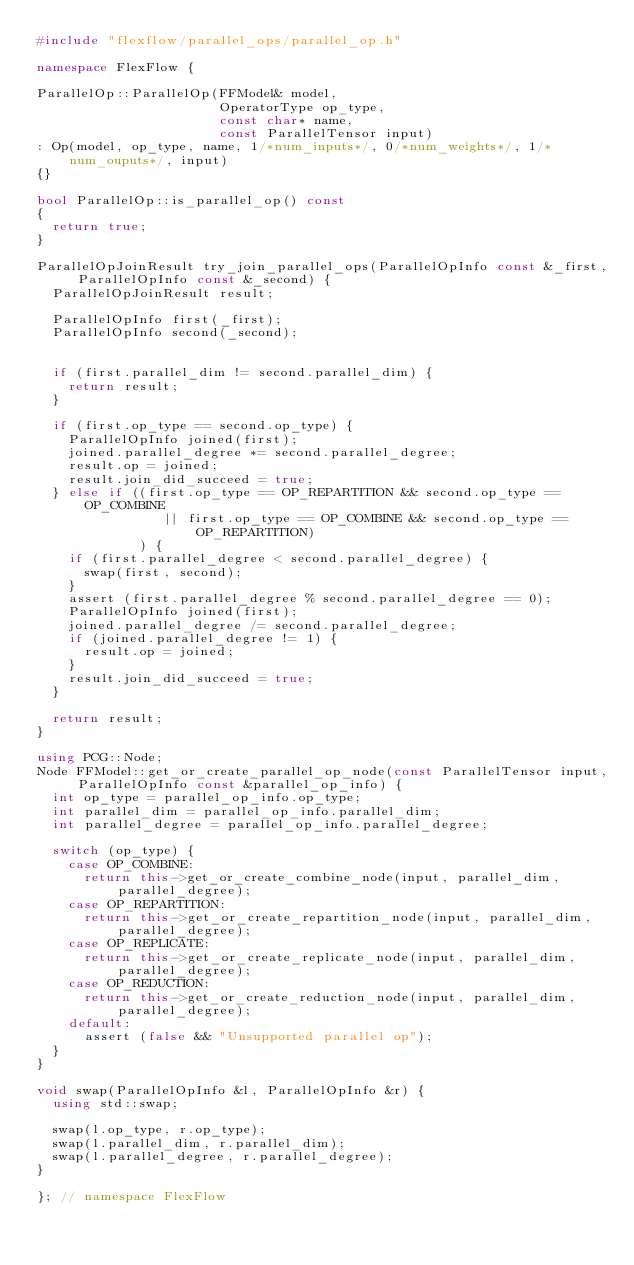Convert code to text. <code><loc_0><loc_0><loc_500><loc_500><_C++_>#include "flexflow/parallel_ops/parallel_op.h"

namespace FlexFlow {

ParallelOp::ParallelOp(FFModel& model,
                       OperatorType op_type,
                       const char* name,
                       const ParallelTensor input)
: Op(model, op_type, name, 1/*num_inputs*/, 0/*num_weights*/, 1/*num_ouputs*/, input)
{}

bool ParallelOp::is_parallel_op() const
{
  return true;
}

ParallelOpJoinResult try_join_parallel_ops(ParallelOpInfo const &_first, ParallelOpInfo const &_second) {
  ParallelOpJoinResult result;

  ParallelOpInfo first(_first);
  ParallelOpInfo second(_second);


  if (first.parallel_dim != second.parallel_dim) {
    return result;
  }
  
  if (first.op_type == second.op_type) {
    ParallelOpInfo joined(first);
    joined.parallel_degree *= second.parallel_degree;
    result.op = joined;
    result.join_did_succeed = true;
  } else if ((first.op_type == OP_REPARTITION && second.op_type == OP_COMBINE
                || first.op_type == OP_COMBINE && second.op_type == OP_REPARTITION) 
             ) {
    if (first.parallel_degree < second.parallel_degree) {
      swap(first, second);
    }
    assert (first.parallel_degree % second.parallel_degree == 0);
    ParallelOpInfo joined(first);
    joined.parallel_degree /= second.parallel_degree;
    if (joined.parallel_degree != 1) {
      result.op = joined;
    }
    result.join_did_succeed = true;
  } 

  return result;
}

using PCG::Node;
Node FFModel::get_or_create_parallel_op_node(const ParallelTensor input, ParallelOpInfo const &parallel_op_info) {
  int op_type = parallel_op_info.op_type;
  int parallel_dim = parallel_op_info.parallel_dim;
  int parallel_degree = parallel_op_info.parallel_degree;

  switch (op_type) {
    case OP_COMBINE:
      return this->get_or_create_combine_node(input, parallel_dim, parallel_degree);
    case OP_REPARTITION:
      return this->get_or_create_repartition_node(input, parallel_dim, parallel_degree);
    case OP_REPLICATE:
      return this->get_or_create_replicate_node(input, parallel_dim, parallel_degree);
    case OP_REDUCTION:
      return this->get_or_create_reduction_node(input, parallel_dim, parallel_degree);
    default:
      assert (false && "Unsupported parallel op");
  }
}

void swap(ParallelOpInfo &l, ParallelOpInfo &r) {
  using std::swap;

  swap(l.op_type, r.op_type);
  swap(l.parallel_dim, r.parallel_dim);
  swap(l.parallel_degree, r.parallel_degree);
}

}; // namespace FlexFlow
</code> 